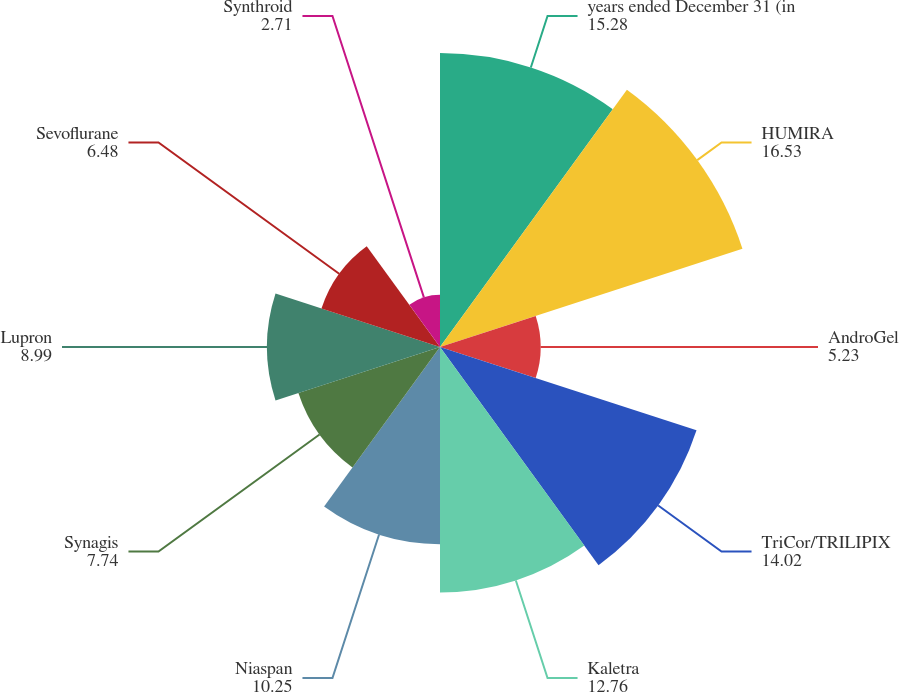Convert chart. <chart><loc_0><loc_0><loc_500><loc_500><pie_chart><fcel>years ended December 31 (in<fcel>HUMIRA<fcel>AndroGel<fcel>TriCor/TRILIPIX<fcel>Kaletra<fcel>Niaspan<fcel>Synagis<fcel>Lupron<fcel>Sevoflurane<fcel>Synthroid<nl><fcel>15.28%<fcel>16.53%<fcel>5.23%<fcel>14.02%<fcel>12.76%<fcel>10.25%<fcel>7.74%<fcel>8.99%<fcel>6.48%<fcel>2.71%<nl></chart> 